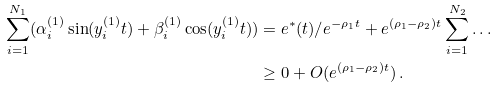Convert formula to latex. <formula><loc_0><loc_0><loc_500><loc_500>\sum _ { i = 1 } ^ { N _ { 1 } } ( \alpha _ { i } ^ { ( 1 ) } \sin ( y _ { i } ^ { ( 1 ) } t ) + \beta _ { i } ^ { ( 1 ) } \cos ( y _ { i } ^ { ( 1 ) } t ) ) & = e ^ { * } ( t ) / e ^ { - \rho _ { 1 } t } + e ^ { ( \rho _ { 1 } - \rho _ { 2 } ) t } \sum _ { i = 1 } ^ { N _ { 2 } } \dots \\ & \geq 0 + O ( e ^ { ( \rho _ { 1 } - \rho _ { 2 } ) t } ) \, .</formula> 